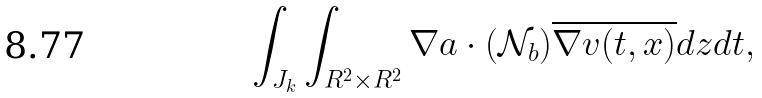<formula> <loc_0><loc_0><loc_500><loc_500>\int _ { J _ { k } } \int _ { R ^ { 2 } \times R ^ { 2 } } \nabla a \cdot ( \mathcal { N } _ { b } ) \overline { \nabla v ( t , x ) } d z d t ,</formula> 